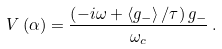<formula> <loc_0><loc_0><loc_500><loc_500>V \left ( \alpha \right ) = \frac { \left ( - i \omega + \left \langle g _ { - } \right \rangle / \tau \right ) g _ { - } } { \omega _ { c } } \, .</formula> 